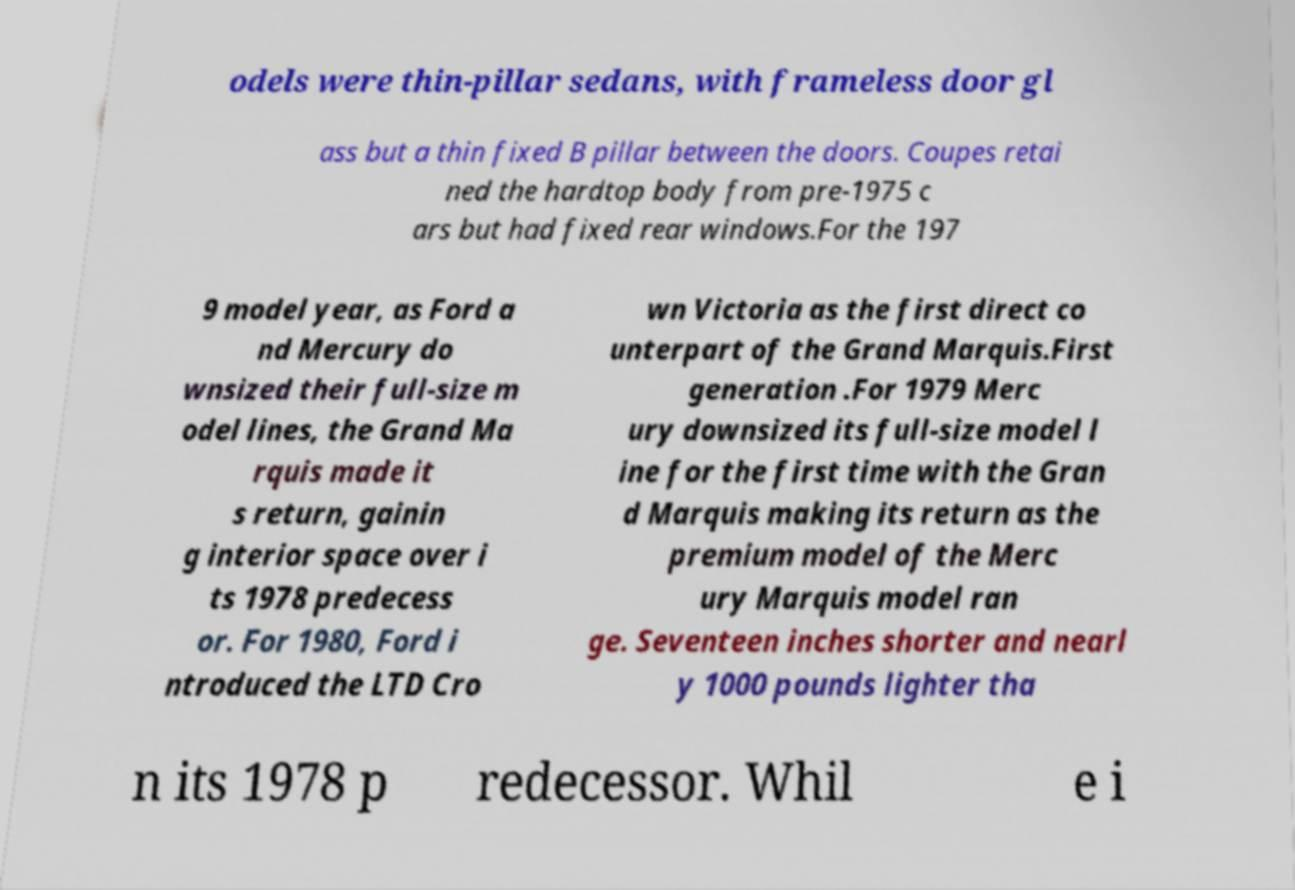I need the written content from this picture converted into text. Can you do that? odels were thin-pillar sedans, with frameless door gl ass but a thin fixed B pillar between the doors. Coupes retai ned the hardtop body from pre-1975 c ars but had fixed rear windows.For the 197 9 model year, as Ford a nd Mercury do wnsized their full-size m odel lines, the Grand Ma rquis made it s return, gainin g interior space over i ts 1978 predecess or. For 1980, Ford i ntroduced the LTD Cro wn Victoria as the first direct co unterpart of the Grand Marquis.First generation .For 1979 Merc ury downsized its full-size model l ine for the first time with the Gran d Marquis making its return as the premium model of the Merc ury Marquis model ran ge. Seventeen inches shorter and nearl y 1000 pounds lighter tha n its 1978 p redecessor. Whil e i 